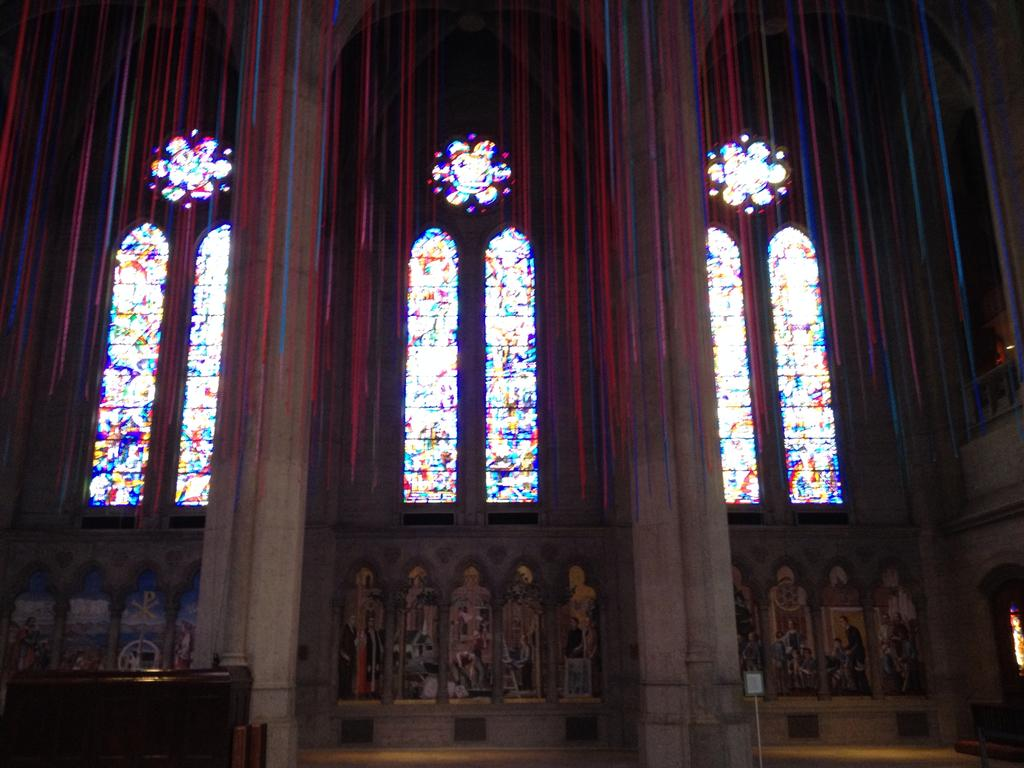What type of building is the image taken inside? The image is taken inside a church. What can be seen in the foreground of the image? There are three windows, two pillars, and a bench in the foreground of the image. Are there any decorative elements on the walls in the image? Yes, there are paintings on the wall in the image. What type of flight can be seen taking off from the church in the image? There is no flight or airplane visible in the image; it is taken inside a church. What type of cast is present in the image? There is no cast or injured person visible in the image. 